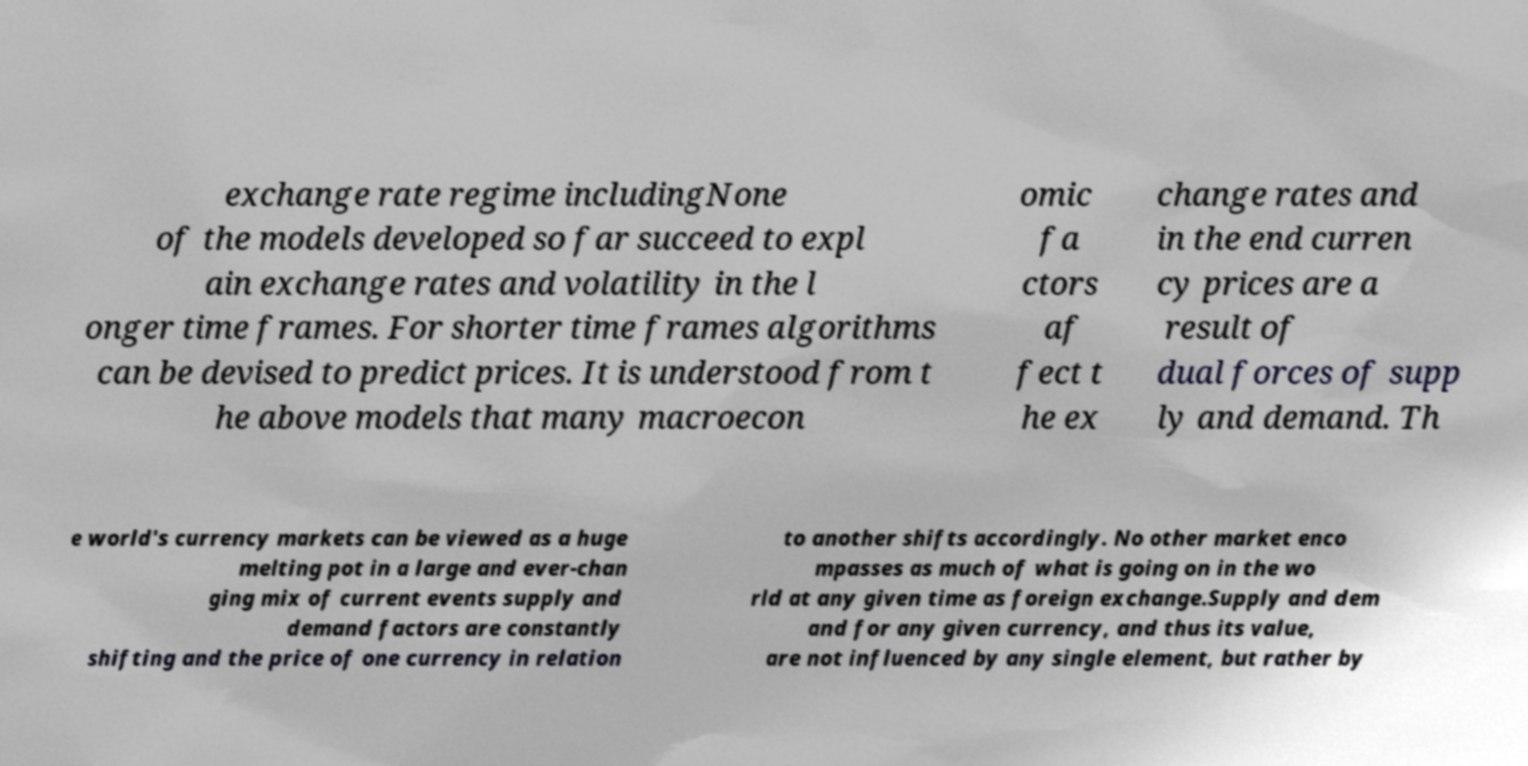Could you extract and type out the text from this image? exchange rate regime includingNone of the models developed so far succeed to expl ain exchange rates and volatility in the l onger time frames. For shorter time frames algorithms can be devised to predict prices. It is understood from t he above models that many macroecon omic fa ctors af fect t he ex change rates and in the end curren cy prices are a result of dual forces of supp ly and demand. Th e world's currency markets can be viewed as a huge melting pot in a large and ever-chan ging mix of current events supply and demand factors are constantly shifting and the price of one currency in relation to another shifts accordingly. No other market enco mpasses as much of what is going on in the wo rld at any given time as foreign exchange.Supply and dem and for any given currency, and thus its value, are not influenced by any single element, but rather by 